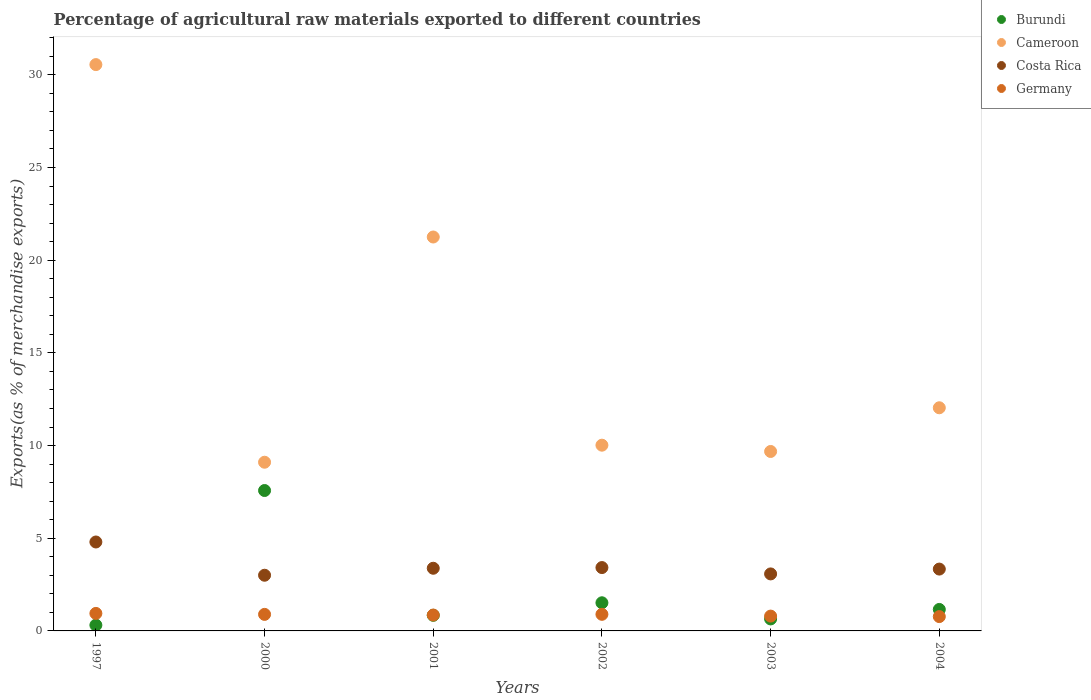Is the number of dotlines equal to the number of legend labels?
Provide a short and direct response. Yes. What is the percentage of exports to different countries in Cameroon in 2003?
Give a very brief answer. 9.68. Across all years, what is the maximum percentage of exports to different countries in Burundi?
Give a very brief answer. 7.57. Across all years, what is the minimum percentage of exports to different countries in Costa Rica?
Keep it short and to the point. 3. In which year was the percentage of exports to different countries in Cameroon maximum?
Your response must be concise. 1997. What is the total percentage of exports to different countries in Cameroon in the graph?
Offer a very short reply. 92.64. What is the difference between the percentage of exports to different countries in Burundi in 2000 and that in 2003?
Offer a very short reply. 6.93. What is the difference between the percentage of exports to different countries in Costa Rica in 2002 and the percentage of exports to different countries in Burundi in 1997?
Provide a short and direct response. 3.1. What is the average percentage of exports to different countries in Burundi per year?
Provide a succinct answer. 2.01. In the year 2001, what is the difference between the percentage of exports to different countries in Cameroon and percentage of exports to different countries in Costa Rica?
Your answer should be very brief. 17.87. What is the ratio of the percentage of exports to different countries in Costa Rica in 2000 to that in 2002?
Give a very brief answer. 0.88. Is the difference between the percentage of exports to different countries in Cameroon in 2000 and 2002 greater than the difference between the percentage of exports to different countries in Costa Rica in 2000 and 2002?
Your answer should be compact. No. What is the difference between the highest and the second highest percentage of exports to different countries in Burundi?
Your response must be concise. 6.06. What is the difference between the highest and the lowest percentage of exports to different countries in Cameroon?
Ensure brevity in your answer.  21.45. In how many years, is the percentage of exports to different countries in Costa Rica greater than the average percentage of exports to different countries in Costa Rica taken over all years?
Offer a very short reply. 1. Is the sum of the percentage of exports to different countries in Costa Rica in 2000 and 2003 greater than the maximum percentage of exports to different countries in Burundi across all years?
Ensure brevity in your answer.  No. Is it the case that in every year, the sum of the percentage of exports to different countries in Costa Rica and percentage of exports to different countries in Cameroon  is greater than the sum of percentage of exports to different countries in Germany and percentage of exports to different countries in Burundi?
Your answer should be very brief. Yes. Is it the case that in every year, the sum of the percentage of exports to different countries in Germany and percentage of exports to different countries in Burundi  is greater than the percentage of exports to different countries in Cameroon?
Offer a very short reply. No. Does the percentage of exports to different countries in Germany monotonically increase over the years?
Offer a terse response. No. Is the percentage of exports to different countries in Cameroon strictly less than the percentage of exports to different countries in Germany over the years?
Your answer should be very brief. No. Are the values on the major ticks of Y-axis written in scientific E-notation?
Offer a very short reply. No. Does the graph contain grids?
Provide a succinct answer. No. How are the legend labels stacked?
Your answer should be very brief. Vertical. What is the title of the graph?
Give a very brief answer. Percentage of agricultural raw materials exported to different countries. What is the label or title of the X-axis?
Your answer should be very brief. Years. What is the label or title of the Y-axis?
Keep it short and to the point. Exports(as % of merchandise exports). What is the Exports(as % of merchandise exports) in Burundi in 1997?
Offer a terse response. 0.31. What is the Exports(as % of merchandise exports) in Cameroon in 1997?
Offer a very short reply. 30.55. What is the Exports(as % of merchandise exports) in Costa Rica in 1997?
Keep it short and to the point. 4.8. What is the Exports(as % of merchandise exports) of Germany in 1997?
Provide a short and direct response. 0.94. What is the Exports(as % of merchandise exports) in Burundi in 2000?
Provide a short and direct response. 7.57. What is the Exports(as % of merchandise exports) in Cameroon in 2000?
Provide a short and direct response. 9.1. What is the Exports(as % of merchandise exports) in Costa Rica in 2000?
Make the answer very short. 3. What is the Exports(as % of merchandise exports) in Germany in 2000?
Offer a very short reply. 0.89. What is the Exports(as % of merchandise exports) in Burundi in 2001?
Provide a short and direct response. 0.84. What is the Exports(as % of merchandise exports) of Cameroon in 2001?
Provide a short and direct response. 21.25. What is the Exports(as % of merchandise exports) in Costa Rica in 2001?
Keep it short and to the point. 3.38. What is the Exports(as % of merchandise exports) of Germany in 2001?
Give a very brief answer. 0.86. What is the Exports(as % of merchandise exports) of Burundi in 2002?
Keep it short and to the point. 1.52. What is the Exports(as % of merchandise exports) in Cameroon in 2002?
Your answer should be very brief. 10.02. What is the Exports(as % of merchandise exports) in Costa Rica in 2002?
Ensure brevity in your answer.  3.42. What is the Exports(as % of merchandise exports) of Germany in 2002?
Offer a very short reply. 0.9. What is the Exports(as % of merchandise exports) of Burundi in 2003?
Ensure brevity in your answer.  0.65. What is the Exports(as % of merchandise exports) of Cameroon in 2003?
Make the answer very short. 9.68. What is the Exports(as % of merchandise exports) of Costa Rica in 2003?
Give a very brief answer. 3.08. What is the Exports(as % of merchandise exports) in Germany in 2003?
Your answer should be very brief. 0.8. What is the Exports(as % of merchandise exports) in Burundi in 2004?
Give a very brief answer. 1.16. What is the Exports(as % of merchandise exports) in Cameroon in 2004?
Offer a terse response. 12.04. What is the Exports(as % of merchandise exports) in Costa Rica in 2004?
Offer a terse response. 3.34. What is the Exports(as % of merchandise exports) of Germany in 2004?
Give a very brief answer. 0.77. Across all years, what is the maximum Exports(as % of merchandise exports) in Burundi?
Your response must be concise. 7.57. Across all years, what is the maximum Exports(as % of merchandise exports) of Cameroon?
Provide a short and direct response. 30.55. Across all years, what is the maximum Exports(as % of merchandise exports) of Costa Rica?
Your answer should be compact. 4.8. Across all years, what is the maximum Exports(as % of merchandise exports) of Germany?
Your response must be concise. 0.94. Across all years, what is the minimum Exports(as % of merchandise exports) of Burundi?
Provide a succinct answer. 0.31. Across all years, what is the minimum Exports(as % of merchandise exports) of Cameroon?
Make the answer very short. 9.1. Across all years, what is the minimum Exports(as % of merchandise exports) of Costa Rica?
Your response must be concise. 3. Across all years, what is the minimum Exports(as % of merchandise exports) in Germany?
Provide a short and direct response. 0.77. What is the total Exports(as % of merchandise exports) of Burundi in the graph?
Offer a very short reply. 12.05. What is the total Exports(as % of merchandise exports) in Cameroon in the graph?
Provide a succinct answer. 92.64. What is the total Exports(as % of merchandise exports) in Costa Rica in the graph?
Offer a very short reply. 21.01. What is the total Exports(as % of merchandise exports) of Germany in the graph?
Your answer should be compact. 5.16. What is the difference between the Exports(as % of merchandise exports) in Burundi in 1997 and that in 2000?
Your answer should be compact. -7.26. What is the difference between the Exports(as % of merchandise exports) in Cameroon in 1997 and that in 2000?
Keep it short and to the point. 21.45. What is the difference between the Exports(as % of merchandise exports) in Costa Rica in 1997 and that in 2000?
Offer a very short reply. 1.79. What is the difference between the Exports(as % of merchandise exports) of Germany in 1997 and that in 2000?
Offer a very short reply. 0.05. What is the difference between the Exports(as % of merchandise exports) in Burundi in 1997 and that in 2001?
Provide a succinct answer. -0.53. What is the difference between the Exports(as % of merchandise exports) in Cameroon in 1997 and that in 2001?
Keep it short and to the point. 9.3. What is the difference between the Exports(as % of merchandise exports) in Costa Rica in 1997 and that in 2001?
Keep it short and to the point. 1.42. What is the difference between the Exports(as % of merchandise exports) of Germany in 1997 and that in 2001?
Ensure brevity in your answer.  0.09. What is the difference between the Exports(as % of merchandise exports) of Burundi in 1997 and that in 2002?
Provide a short and direct response. -1.21. What is the difference between the Exports(as % of merchandise exports) in Cameroon in 1997 and that in 2002?
Your response must be concise. 20.53. What is the difference between the Exports(as % of merchandise exports) in Costa Rica in 1997 and that in 2002?
Offer a terse response. 1.38. What is the difference between the Exports(as % of merchandise exports) in Germany in 1997 and that in 2002?
Your answer should be very brief. 0.05. What is the difference between the Exports(as % of merchandise exports) in Burundi in 1997 and that in 2003?
Your answer should be compact. -0.33. What is the difference between the Exports(as % of merchandise exports) in Cameroon in 1997 and that in 2003?
Keep it short and to the point. 20.87. What is the difference between the Exports(as % of merchandise exports) in Costa Rica in 1997 and that in 2003?
Offer a terse response. 1.72. What is the difference between the Exports(as % of merchandise exports) in Germany in 1997 and that in 2003?
Your answer should be very brief. 0.14. What is the difference between the Exports(as % of merchandise exports) in Burundi in 1997 and that in 2004?
Offer a very short reply. -0.85. What is the difference between the Exports(as % of merchandise exports) of Cameroon in 1997 and that in 2004?
Provide a succinct answer. 18.51. What is the difference between the Exports(as % of merchandise exports) in Costa Rica in 1997 and that in 2004?
Give a very brief answer. 1.46. What is the difference between the Exports(as % of merchandise exports) in Germany in 1997 and that in 2004?
Keep it short and to the point. 0.17. What is the difference between the Exports(as % of merchandise exports) in Burundi in 2000 and that in 2001?
Ensure brevity in your answer.  6.73. What is the difference between the Exports(as % of merchandise exports) of Cameroon in 2000 and that in 2001?
Make the answer very short. -12.15. What is the difference between the Exports(as % of merchandise exports) of Costa Rica in 2000 and that in 2001?
Your answer should be very brief. -0.38. What is the difference between the Exports(as % of merchandise exports) of Germany in 2000 and that in 2001?
Keep it short and to the point. 0.04. What is the difference between the Exports(as % of merchandise exports) of Burundi in 2000 and that in 2002?
Give a very brief answer. 6.06. What is the difference between the Exports(as % of merchandise exports) in Cameroon in 2000 and that in 2002?
Provide a succinct answer. -0.92. What is the difference between the Exports(as % of merchandise exports) of Costa Rica in 2000 and that in 2002?
Your answer should be compact. -0.41. What is the difference between the Exports(as % of merchandise exports) in Germany in 2000 and that in 2002?
Make the answer very short. -0. What is the difference between the Exports(as % of merchandise exports) of Burundi in 2000 and that in 2003?
Your answer should be very brief. 6.93. What is the difference between the Exports(as % of merchandise exports) in Cameroon in 2000 and that in 2003?
Ensure brevity in your answer.  -0.58. What is the difference between the Exports(as % of merchandise exports) in Costa Rica in 2000 and that in 2003?
Give a very brief answer. -0.07. What is the difference between the Exports(as % of merchandise exports) in Germany in 2000 and that in 2003?
Offer a very short reply. 0.09. What is the difference between the Exports(as % of merchandise exports) in Burundi in 2000 and that in 2004?
Provide a succinct answer. 6.42. What is the difference between the Exports(as % of merchandise exports) in Cameroon in 2000 and that in 2004?
Your answer should be very brief. -2.94. What is the difference between the Exports(as % of merchandise exports) of Costa Rica in 2000 and that in 2004?
Offer a terse response. -0.33. What is the difference between the Exports(as % of merchandise exports) of Germany in 2000 and that in 2004?
Your answer should be very brief. 0.12. What is the difference between the Exports(as % of merchandise exports) in Burundi in 2001 and that in 2002?
Make the answer very short. -0.68. What is the difference between the Exports(as % of merchandise exports) in Cameroon in 2001 and that in 2002?
Offer a very short reply. 11.23. What is the difference between the Exports(as % of merchandise exports) of Costa Rica in 2001 and that in 2002?
Make the answer very short. -0.04. What is the difference between the Exports(as % of merchandise exports) in Germany in 2001 and that in 2002?
Your answer should be very brief. -0.04. What is the difference between the Exports(as % of merchandise exports) of Burundi in 2001 and that in 2003?
Keep it short and to the point. 0.19. What is the difference between the Exports(as % of merchandise exports) of Cameroon in 2001 and that in 2003?
Provide a succinct answer. 11.57. What is the difference between the Exports(as % of merchandise exports) of Costa Rica in 2001 and that in 2003?
Ensure brevity in your answer.  0.31. What is the difference between the Exports(as % of merchandise exports) of Germany in 2001 and that in 2003?
Ensure brevity in your answer.  0.06. What is the difference between the Exports(as % of merchandise exports) in Burundi in 2001 and that in 2004?
Offer a terse response. -0.32. What is the difference between the Exports(as % of merchandise exports) of Cameroon in 2001 and that in 2004?
Provide a succinct answer. 9.21. What is the difference between the Exports(as % of merchandise exports) in Costa Rica in 2001 and that in 2004?
Provide a succinct answer. 0.04. What is the difference between the Exports(as % of merchandise exports) in Germany in 2001 and that in 2004?
Your answer should be compact. 0.08. What is the difference between the Exports(as % of merchandise exports) in Burundi in 2002 and that in 2003?
Your answer should be very brief. 0.87. What is the difference between the Exports(as % of merchandise exports) in Cameroon in 2002 and that in 2003?
Give a very brief answer. 0.34. What is the difference between the Exports(as % of merchandise exports) in Costa Rica in 2002 and that in 2003?
Give a very brief answer. 0.34. What is the difference between the Exports(as % of merchandise exports) of Germany in 2002 and that in 2003?
Offer a very short reply. 0.1. What is the difference between the Exports(as % of merchandise exports) of Burundi in 2002 and that in 2004?
Make the answer very short. 0.36. What is the difference between the Exports(as % of merchandise exports) of Cameroon in 2002 and that in 2004?
Your response must be concise. -2.02. What is the difference between the Exports(as % of merchandise exports) in Costa Rica in 2002 and that in 2004?
Make the answer very short. 0.08. What is the difference between the Exports(as % of merchandise exports) of Germany in 2002 and that in 2004?
Give a very brief answer. 0.12. What is the difference between the Exports(as % of merchandise exports) of Burundi in 2003 and that in 2004?
Provide a short and direct response. -0.51. What is the difference between the Exports(as % of merchandise exports) of Cameroon in 2003 and that in 2004?
Your answer should be very brief. -2.36. What is the difference between the Exports(as % of merchandise exports) in Costa Rica in 2003 and that in 2004?
Your answer should be compact. -0.26. What is the difference between the Exports(as % of merchandise exports) of Germany in 2003 and that in 2004?
Ensure brevity in your answer.  0.03. What is the difference between the Exports(as % of merchandise exports) in Burundi in 1997 and the Exports(as % of merchandise exports) in Cameroon in 2000?
Offer a terse response. -8.79. What is the difference between the Exports(as % of merchandise exports) in Burundi in 1997 and the Exports(as % of merchandise exports) in Costa Rica in 2000?
Give a very brief answer. -2.69. What is the difference between the Exports(as % of merchandise exports) in Burundi in 1997 and the Exports(as % of merchandise exports) in Germany in 2000?
Offer a terse response. -0.58. What is the difference between the Exports(as % of merchandise exports) of Cameroon in 1997 and the Exports(as % of merchandise exports) of Costa Rica in 2000?
Ensure brevity in your answer.  27.55. What is the difference between the Exports(as % of merchandise exports) of Cameroon in 1997 and the Exports(as % of merchandise exports) of Germany in 2000?
Provide a succinct answer. 29.66. What is the difference between the Exports(as % of merchandise exports) in Costa Rica in 1997 and the Exports(as % of merchandise exports) in Germany in 2000?
Your answer should be very brief. 3.91. What is the difference between the Exports(as % of merchandise exports) in Burundi in 1997 and the Exports(as % of merchandise exports) in Cameroon in 2001?
Your answer should be very brief. -20.94. What is the difference between the Exports(as % of merchandise exports) in Burundi in 1997 and the Exports(as % of merchandise exports) in Costa Rica in 2001?
Make the answer very short. -3.07. What is the difference between the Exports(as % of merchandise exports) in Burundi in 1997 and the Exports(as % of merchandise exports) in Germany in 2001?
Your answer should be compact. -0.54. What is the difference between the Exports(as % of merchandise exports) of Cameroon in 1997 and the Exports(as % of merchandise exports) of Costa Rica in 2001?
Keep it short and to the point. 27.17. What is the difference between the Exports(as % of merchandise exports) in Cameroon in 1997 and the Exports(as % of merchandise exports) in Germany in 2001?
Ensure brevity in your answer.  29.69. What is the difference between the Exports(as % of merchandise exports) of Costa Rica in 1997 and the Exports(as % of merchandise exports) of Germany in 2001?
Ensure brevity in your answer.  3.94. What is the difference between the Exports(as % of merchandise exports) of Burundi in 1997 and the Exports(as % of merchandise exports) of Cameroon in 2002?
Offer a very short reply. -9.71. What is the difference between the Exports(as % of merchandise exports) of Burundi in 1997 and the Exports(as % of merchandise exports) of Costa Rica in 2002?
Give a very brief answer. -3.1. What is the difference between the Exports(as % of merchandise exports) in Burundi in 1997 and the Exports(as % of merchandise exports) in Germany in 2002?
Offer a terse response. -0.58. What is the difference between the Exports(as % of merchandise exports) of Cameroon in 1997 and the Exports(as % of merchandise exports) of Costa Rica in 2002?
Provide a short and direct response. 27.13. What is the difference between the Exports(as % of merchandise exports) of Cameroon in 1997 and the Exports(as % of merchandise exports) of Germany in 2002?
Ensure brevity in your answer.  29.66. What is the difference between the Exports(as % of merchandise exports) of Costa Rica in 1997 and the Exports(as % of merchandise exports) of Germany in 2002?
Your answer should be compact. 3.9. What is the difference between the Exports(as % of merchandise exports) in Burundi in 1997 and the Exports(as % of merchandise exports) in Cameroon in 2003?
Make the answer very short. -9.37. What is the difference between the Exports(as % of merchandise exports) of Burundi in 1997 and the Exports(as % of merchandise exports) of Costa Rica in 2003?
Provide a short and direct response. -2.76. What is the difference between the Exports(as % of merchandise exports) in Burundi in 1997 and the Exports(as % of merchandise exports) in Germany in 2003?
Provide a succinct answer. -0.49. What is the difference between the Exports(as % of merchandise exports) of Cameroon in 1997 and the Exports(as % of merchandise exports) of Costa Rica in 2003?
Provide a succinct answer. 27.48. What is the difference between the Exports(as % of merchandise exports) in Cameroon in 1997 and the Exports(as % of merchandise exports) in Germany in 2003?
Your response must be concise. 29.75. What is the difference between the Exports(as % of merchandise exports) of Costa Rica in 1997 and the Exports(as % of merchandise exports) of Germany in 2003?
Provide a succinct answer. 4. What is the difference between the Exports(as % of merchandise exports) of Burundi in 1997 and the Exports(as % of merchandise exports) of Cameroon in 2004?
Offer a very short reply. -11.73. What is the difference between the Exports(as % of merchandise exports) of Burundi in 1997 and the Exports(as % of merchandise exports) of Costa Rica in 2004?
Offer a very short reply. -3.02. What is the difference between the Exports(as % of merchandise exports) in Burundi in 1997 and the Exports(as % of merchandise exports) in Germany in 2004?
Provide a short and direct response. -0.46. What is the difference between the Exports(as % of merchandise exports) of Cameroon in 1997 and the Exports(as % of merchandise exports) of Costa Rica in 2004?
Offer a very short reply. 27.21. What is the difference between the Exports(as % of merchandise exports) in Cameroon in 1997 and the Exports(as % of merchandise exports) in Germany in 2004?
Offer a terse response. 29.78. What is the difference between the Exports(as % of merchandise exports) of Costa Rica in 1997 and the Exports(as % of merchandise exports) of Germany in 2004?
Make the answer very short. 4.02. What is the difference between the Exports(as % of merchandise exports) in Burundi in 2000 and the Exports(as % of merchandise exports) in Cameroon in 2001?
Give a very brief answer. -13.68. What is the difference between the Exports(as % of merchandise exports) in Burundi in 2000 and the Exports(as % of merchandise exports) in Costa Rica in 2001?
Offer a terse response. 4.19. What is the difference between the Exports(as % of merchandise exports) in Burundi in 2000 and the Exports(as % of merchandise exports) in Germany in 2001?
Provide a succinct answer. 6.72. What is the difference between the Exports(as % of merchandise exports) in Cameroon in 2000 and the Exports(as % of merchandise exports) in Costa Rica in 2001?
Provide a short and direct response. 5.72. What is the difference between the Exports(as % of merchandise exports) of Cameroon in 2000 and the Exports(as % of merchandise exports) of Germany in 2001?
Offer a very short reply. 8.24. What is the difference between the Exports(as % of merchandise exports) in Costa Rica in 2000 and the Exports(as % of merchandise exports) in Germany in 2001?
Provide a succinct answer. 2.15. What is the difference between the Exports(as % of merchandise exports) in Burundi in 2000 and the Exports(as % of merchandise exports) in Cameroon in 2002?
Make the answer very short. -2.45. What is the difference between the Exports(as % of merchandise exports) in Burundi in 2000 and the Exports(as % of merchandise exports) in Costa Rica in 2002?
Your answer should be very brief. 4.16. What is the difference between the Exports(as % of merchandise exports) of Burundi in 2000 and the Exports(as % of merchandise exports) of Germany in 2002?
Offer a very short reply. 6.68. What is the difference between the Exports(as % of merchandise exports) in Cameroon in 2000 and the Exports(as % of merchandise exports) in Costa Rica in 2002?
Ensure brevity in your answer.  5.68. What is the difference between the Exports(as % of merchandise exports) in Cameroon in 2000 and the Exports(as % of merchandise exports) in Germany in 2002?
Ensure brevity in your answer.  8.2. What is the difference between the Exports(as % of merchandise exports) of Costa Rica in 2000 and the Exports(as % of merchandise exports) of Germany in 2002?
Provide a short and direct response. 2.11. What is the difference between the Exports(as % of merchandise exports) of Burundi in 2000 and the Exports(as % of merchandise exports) of Cameroon in 2003?
Your answer should be compact. -2.11. What is the difference between the Exports(as % of merchandise exports) in Burundi in 2000 and the Exports(as % of merchandise exports) in Costa Rica in 2003?
Give a very brief answer. 4.5. What is the difference between the Exports(as % of merchandise exports) of Burundi in 2000 and the Exports(as % of merchandise exports) of Germany in 2003?
Your answer should be compact. 6.77. What is the difference between the Exports(as % of merchandise exports) of Cameroon in 2000 and the Exports(as % of merchandise exports) of Costa Rica in 2003?
Your response must be concise. 6.02. What is the difference between the Exports(as % of merchandise exports) in Cameroon in 2000 and the Exports(as % of merchandise exports) in Germany in 2003?
Give a very brief answer. 8.3. What is the difference between the Exports(as % of merchandise exports) of Costa Rica in 2000 and the Exports(as % of merchandise exports) of Germany in 2003?
Make the answer very short. 2.2. What is the difference between the Exports(as % of merchandise exports) of Burundi in 2000 and the Exports(as % of merchandise exports) of Cameroon in 2004?
Ensure brevity in your answer.  -4.46. What is the difference between the Exports(as % of merchandise exports) in Burundi in 2000 and the Exports(as % of merchandise exports) in Costa Rica in 2004?
Ensure brevity in your answer.  4.24. What is the difference between the Exports(as % of merchandise exports) of Burundi in 2000 and the Exports(as % of merchandise exports) of Germany in 2004?
Your answer should be compact. 6.8. What is the difference between the Exports(as % of merchandise exports) of Cameroon in 2000 and the Exports(as % of merchandise exports) of Costa Rica in 2004?
Provide a short and direct response. 5.76. What is the difference between the Exports(as % of merchandise exports) in Cameroon in 2000 and the Exports(as % of merchandise exports) in Germany in 2004?
Provide a short and direct response. 8.33. What is the difference between the Exports(as % of merchandise exports) in Costa Rica in 2000 and the Exports(as % of merchandise exports) in Germany in 2004?
Keep it short and to the point. 2.23. What is the difference between the Exports(as % of merchandise exports) of Burundi in 2001 and the Exports(as % of merchandise exports) of Cameroon in 2002?
Your answer should be compact. -9.18. What is the difference between the Exports(as % of merchandise exports) of Burundi in 2001 and the Exports(as % of merchandise exports) of Costa Rica in 2002?
Ensure brevity in your answer.  -2.58. What is the difference between the Exports(as % of merchandise exports) of Burundi in 2001 and the Exports(as % of merchandise exports) of Germany in 2002?
Make the answer very short. -0.05. What is the difference between the Exports(as % of merchandise exports) of Cameroon in 2001 and the Exports(as % of merchandise exports) of Costa Rica in 2002?
Provide a short and direct response. 17.83. What is the difference between the Exports(as % of merchandise exports) in Cameroon in 2001 and the Exports(as % of merchandise exports) in Germany in 2002?
Your response must be concise. 20.35. What is the difference between the Exports(as % of merchandise exports) of Costa Rica in 2001 and the Exports(as % of merchandise exports) of Germany in 2002?
Your answer should be compact. 2.49. What is the difference between the Exports(as % of merchandise exports) in Burundi in 2001 and the Exports(as % of merchandise exports) in Cameroon in 2003?
Make the answer very short. -8.84. What is the difference between the Exports(as % of merchandise exports) of Burundi in 2001 and the Exports(as % of merchandise exports) of Costa Rica in 2003?
Keep it short and to the point. -2.23. What is the difference between the Exports(as % of merchandise exports) in Burundi in 2001 and the Exports(as % of merchandise exports) in Germany in 2003?
Provide a short and direct response. 0.04. What is the difference between the Exports(as % of merchandise exports) of Cameroon in 2001 and the Exports(as % of merchandise exports) of Costa Rica in 2003?
Give a very brief answer. 18.17. What is the difference between the Exports(as % of merchandise exports) of Cameroon in 2001 and the Exports(as % of merchandise exports) of Germany in 2003?
Keep it short and to the point. 20.45. What is the difference between the Exports(as % of merchandise exports) of Costa Rica in 2001 and the Exports(as % of merchandise exports) of Germany in 2003?
Your answer should be very brief. 2.58. What is the difference between the Exports(as % of merchandise exports) in Burundi in 2001 and the Exports(as % of merchandise exports) in Cameroon in 2004?
Keep it short and to the point. -11.2. What is the difference between the Exports(as % of merchandise exports) of Burundi in 2001 and the Exports(as % of merchandise exports) of Costa Rica in 2004?
Offer a terse response. -2.49. What is the difference between the Exports(as % of merchandise exports) of Burundi in 2001 and the Exports(as % of merchandise exports) of Germany in 2004?
Ensure brevity in your answer.  0.07. What is the difference between the Exports(as % of merchandise exports) of Cameroon in 2001 and the Exports(as % of merchandise exports) of Costa Rica in 2004?
Your answer should be compact. 17.91. What is the difference between the Exports(as % of merchandise exports) in Cameroon in 2001 and the Exports(as % of merchandise exports) in Germany in 2004?
Your answer should be very brief. 20.48. What is the difference between the Exports(as % of merchandise exports) in Costa Rica in 2001 and the Exports(as % of merchandise exports) in Germany in 2004?
Provide a succinct answer. 2.61. What is the difference between the Exports(as % of merchandise exports) in Burundi in 2002 and the Exports(as % of merchandise exports) in Cameroon in 2003?
Offer a very short reply. -8.16. What is the difference between the Exports(as % of merchandise exports) of Burundi in 2002 and the Exports(as % of merchandise exports) of Costa Rica in 2003?
Provide a succinct answer. -1.56. What is the difference between the Exports(as % of merchandise exports) in Burundi in 2002 and the Exports(as % of merchandise exports) in Germany in 2003?
Offer a very short reply. 0.72. What is the difference between the Exports(as % of merchandise exports) of Cameroon in 2002 and the Exports(as % of merchandise exports) of Costa Rica in 2003?
Your answer should be very brief. 6.94. What is the difference between the Exports(as % of merchandise exports) in Cameroon in 2002 and the Exports(as % of merchandise exports) in Germany in 2003?
Offer a very short reply. 9.22. What is the difference between the Exports(as % of merchandise exports) of Costa Rica in 2002 and the Exports(as % of merchandise exports) of Germany in 2003?
Keep it short and to the point. 2.62. What is the difference between the Exports(as % of merchandise exports) of Burundi in 2002 and the Exports(as % of merchandise exports) of Cameroon in 2004?
Your answer should be very brief. -10.52. What is the difference between the Exports(as % of merchandise exports) in Burundi in 2002 and the Exports(as % of merchandise exports) in Costa Rica in 2004?
Ensure brevity in your answer.  -1.82. What is the difference between the Exports(as % of merchandise exports) of Burundi in 2002 and the Exports(as % of merchandise exports) of Germany in 2004?
Make the answer very short. 0.74. What is the difference between the Exports(as % of merchandise exports) in Cameroon in 2002 and the Exports(as % of merchandise exports) in Costa Rica in 2004?
Provide a succinct answer. 6.68. What is the difference between the Exports(as % of merchandise exports) in Cameroon in 2002 and the Exports(as % of merchandise exports) in Germany in 2004?
Keep it short and to the point. 9.25. What is the difference between the Exports(as % of merchandise exports) of Costa Rica in 2002 and the Exports(as % of merchandise exports) of Germany in 2004?
Offer a terse response. 2.64. What is the difference between the Exports(as % of merchandise exports) in Burundi in 2003 and the Exports(as % of merchandise exports) in Cameroon in 2004?
Your answer should be compact. -11.39. What is the difference between the Exports(as % of merchandise exports) in Burundi in 2003 and the Exports(as % of merchandise exports) in Costa Rica in 2004?
Provide a short and direct response. -2.69. What is the difference between the Exports(as % of merchandise exports) in Burundi in 2003 and the Exports(as % of merchandise exports) in Germany in 2004?
Your answer should be compact. -0.13. What is the difference between the Exports(as % of merchandise exports) in Cameroon in 2003 and the Exports(as % of merchandise exports) in Costa Rica in 2004?
Provide a succinct answer. 6.34. What is the difference between the Exports(as % of merchandise exports) of Cameroon in 2003 and the Exports(as % of merchandise exports) of Germany in 2004?
Keep it short and to the point. 8.91. What is the difference between the Exports(as % of merchandise exports) of Costa Rica in 2003 and the Exports(as % of merchandise exports) of Germany in 2004?
Keep it short and to the point. 2.3. What is the average Exports(as % of merchandise exports) in Burundi per year?
Give a very brief answer. 2.01. What is the average Exports(as % of merchandise exports) of Cameroon per year?
Give a very brief answer. 15.44. What is the average Exports(as % of merchandise exports) of Costa Rica per year?
Offer a very short reply. 3.5. What is the average Exports(as % of merchandise exports) in Germany per year?
Provide a succinct answer. 0.86. In the year 1997, what is the difference between the Exports(as % of merchandise exports) in Burundi and Exports(as % of merchandise exports) in Cameroon?
Offer a very short reply. -30.24. In the year 1997, what is the difference between the Exports(as % of merchandise exports) in Burundi and Exports(as % of merchandise exports) in Costa Rica?
Make the answer very short. -4.48. In the year 1997, what is the difference between the Exports(as % of merchandise exports) of Burundi and Exports(as % of merchandise exports) of Germany?
Make the answer very short. -0.63. In the year 1997, what is the difference between the Exports(as % of merchandise exports) of Cameroon and Exports(as % of merchandise exports) of Costa Rica?
Make the answer very short. 25.75. In the year 1997, what is the difference between the Exports(as % of merchandise exports) of Cameroon and Exports(as % of merchandise exports) of Germany?
Ensure brevity in your answer.  29.61. In the year 1997, what is the difference between the Exports(as % of merchandise exports) in Costa Rica and Exports(as % of merchandise exports) in Germany?
Provide a succinct answer. 3.85. In the year 2000, what is the difference between the Exports(as % of merchandise exports) in Burundi and Exports(as % of merchandise exports) in Cameroon?
Make the answer very short. -1.53. In the year 2000, what is the difference between the Exports(as % of merchandise exports) in Burundi and Exports(as % of merchandise exports) in Costa Rica?
Give a very brief answer. 4.57. In the year 2000, what is the difference between the Exports(as % of merchandise exports) of Burundi and Exports(as % of merchandise exports) of Germany?
Offer a very short reply. 6.68. In the year 2000, what is the difference between the Exports(as % of merchandise exports) in Cameroon and Exports(as % of merchandise exports) in Costa Rica?
Ensure brevity in your answer.  6.1. In the year 2000, what is the difference between the Exports(as % of merchandise exports) in Cameroon and Exports(as % of merchandise exports) in Germany?
Ensure brevity in your answer.  8.21. In the year 2000, what is the difference between the Exports(as % of merchandise exports) in Costa Rica and Exports(as % of merchandise exports) in Germany?
Your answer should be very brief. 2.11. In the year 2001, what is the difference between the Exports(as % of merchandise exports) of Burundi and Exports(as % of merchandise exports) of Cameroon?
Your answer should be compact. -20.41. In the year 2001, what is the difference between the Exports(as % of merchandise exports) in Burundi and Exports(as % of merchandise exports) in Costa Rica?
Give a very brief answer. -2.54. In the year 2001, what is the difference between the Exports(as % of merchandise exports) in Burundi and Exports(as % of merchandise exports) in Germany?
Keep it short and to the point. -0.02. In the year 2001, what is the difference between the Exports(as % of merchandise exports) of Cameroon and Exports(as % of merchandise exports) of Costa Rica?
Make the answer very short. 17.87. In the year 2001, what is the difference between the Exports(as % of merchandise exports) in Cameroon and Exports(as % of merchandise exports) in Germany?
Offer a terse response. 20.39. In the year 2001, what is the difference between the Exports(as % of merchandise exports) in Costa Rica and Exports(as % of merchandise exports) in Germany?
Ensure brevity in your answer.  2.52. In the year 2002, what is the difference between the Exports(as % of merchandise exports) of Burundi and Exports(as % of merchandise exports) of Cameroon?
Offer a very short reply. -8.5. In the year 2002, what is the difference between the Exports(as % of merchandise exports) in Burundi and Exports(as % of merchandise exports) in Costa Rica?
Your answer should be very brief. -1.9. In the year 2002, what is the difference between the Exports(as % of merchandise exports) of Burundi and Exports(as % of merchandise exports) of Germany?
Offer a terse response. 0.62. In the year 2002, what is the difference between the Exports(as % of merchandise exports) of Cameroon and Exports(as % of merchandise exports) of Costa Rica?
Provide a succinct answer. 6.6. In the year 2002, what is the difference between the Exports(as % of merchandise exports) of Cameroon and Exports(as % of merchandise exports) of Germany?
Ensure brevity in your answer.  9.12. In the year 2002, what is the difference between the Exports(as % of merchandise exports) of Costa Rica and Exports(as % of merchandise exports) of Germany?
Your response must be concise. 2.52. In the year 2003, what is the difference between the Exports(as % of merchandise exports) in Burundi and Exports(as % of merchandise exports) in Cameroon?
Your answer should be compact. -9.03. In the year 2003, what is the difference between the Exports(as % of merchandise exports) of Burundi and Exports(as % of merchandise exports) of Costa Rica?
Your response must be concise. -2.43. In the year 2003, what is the difference between the Exports(as % of merchandise exports) of Burundi and Exports(as % of merchandise exports) of Germany?
Your answer should be very brief. -0.15. In the year 2003, what is the difference between the Exports(as % of merchandise exports) in Cameroon and Exports(as % of merchandise exports) in Costa Rica?
Your response must be concise. 6.61. In the year 2003, what is the difference between the Exports(as % of merchandise exports) of Cameroon and Exports(as % of merchandise exports) of Germany?
Ensure brevity in your answer.  8.88. In the year 2003, what is the difference between the Exports(as % of merchandise exports) in Costa Rica and Exports(as % of merchandise exports) in Germany?
Your answer should be very brief. 2.28. In the year 2004, what is the difference between the Exports(as % of merchandise exports) in Burundi and Exports(as % of merchandise exports) in Cameroon?
Your answer should be very brief. -10.88. In the year 2004, what is the difference between the Exports(as % of merchandise exports) of Burundi and Exports(as % of merchandise exports) of Costa Rica?
Keep it short and to the point. -2.18. In the year 2004, what is the difference between the Exports(as % of merchandise exports) of Burundi and Exports(as % of merchandise exports) of Germany?
Offer a very short reply. 0.39. In the year 2004, what is the difference between the Exports(as % of merchandise exports) of Cameroon and Exports(as % of merchandise exports) of Costa Rica?
Ensure brevity in your answer.  8.7. In the year 2004, what is the difference between the Exports(as % of merchandise exports) of Cameroon and Exports(as % of merchandise exports) of Germany?
Ensure brevity in your answer.  11.26. In the year 2004, what is the difference between the Exports(as % of merchandise exports) in Costa Rica and Exports(as % of merchandise exports) in Germany?
Keep it short and to the point. 2.56. What is the ratio of the Exports(as % of merchandise exports) in Burundi in 1997 to that in 2000?
Your response must be concise. 0.04. What is the ratio of the Exports(as % of merchandise exports) of Cameroon in 1997 to that in 2000?
Your response must be concise. 3.36. What is the ratio of the Exports(as % of merchandise exports) of Costa Rica in 1997 to that in 2000?
Provide a succinct answer. 1.6. What is the ratio of the Exports(as % of merchandise exports) of Germany in 1997 to that in 2000?
Offer a very short reply. 1.06. What is the ratio of the Exports(as % of merchandise exports) in Burundi in 1997 to that in 2001?
Give a very brief answer. 0.37. What is the ratio of the Exports(as % of merchandise exports) in Cameroon in 1997 to that in 2001?
Your response must be concise. 1.44. What is the ratio of the Exports(as % of merchandise exports) in Costa Rica in 1997 to that in 2001?
Your answer should be compact. 1.42. What is the ratio of the Exports(as % of merchandise exports) of Germany in 1997 to that in 2001?
Make the answer very short. 1.1. What is the ratio of the Exports(as % of merchandise exports) of Burundi in 1997 to that in 2002?
Offer a very short reply. 0.21. What is the ratio of the Exports(as % of merchandise exports) of Cameroon in 1997 to that in 2002?
Your answer should be compact. 3.05. What is the ratio of the Exports(as % of merchandise exports) in Costa Rica in 1997 to that in 2002?
Keep it short and to the point. 1.4. What is the ratio of the Exports(as % of merchandise exports) of Germany in 1997 to that in 2002?
Keep it short and to the point. 1.05. What is the ratio of the Exports(as % of merchandise exports) of Burundi in 1997 to that in 2003?
Provide a succinct answer. 0.48. What is the ratio of the Exports(as % of merchandise exports) of Cameroon in 1997 to that in 2003?
Offer a very short reply. 3.16. What is the ratio of the Exports(as % of merchandise exports) in Costa Rica in 1997 to that in 2003?
Offer a terse response. 1.56. What is the ratio of the Exports(as % of merchandise exports) of Germany in 1997 to that in 2003?
Provide a short and direct response. 1.18. What is the ratio of the Exports(as % of merchandise exports) in Burundi in 1997 to that in 2004?
Provide a succinct answer. 0.27. What is the ratio of the Exports(as % of merchandise exports) in Cameroon in 1997 to that in 2004?
Your answer should be very brief. 2.54. What is the ratio of the Exports(as % of merchandise exports) in Costa Rica in 1997 to that in 2004?
Make the answer very short. 1.44. What is the ratio of the Exports(as % of merchandise exports) of Germany in 1997 to that in 2004?
Offer a very short reply. 1.22. What is the ratio of the Exports(as % of merchandise exports) in Burundi in 2000 to that in 2001?
Provide a short and direct response. 9. What is the ratio of the Exports(as % of merchandise exports) in Cameroon in 2000 to that in 2001?
Make the answer very short. 0.43. What is the ratio of the Exports(as % of merchandise exports) of Costa Rica in 2000 to that in 2001?
Offer a very short reply. 0.89. What is the ratio of the Exports(as % of merchandise exports) of Germany in 2000 to that in 2001?
Keep it short and to the point. 1.04. What is the ratio of the Exports(as % of merchandise exports) of Burundi in 2000 to that in 2002?
Provide a short and direct response. 4.99. What is the ratio of the Exports(as % of merchandise exports) of Cameroon in 2000 to that in 2002?
Provide a short and direct response. 0.91. What is the ratio of the Exports(as % of merchandise exports) of Costa Rica in 2000 to that in 2002?
Offer a very short reply. 0.88. What is the ratio of the Exports(as % of merchandise exports) in Germany in 2000 to that in 2002?
Provide a short and direct response. 1. What is the ratio of the Exports(as % of merchandise exports) in Burundi in 2000 to that in 2003?
Give a very brief answer. 11.71. What is the ratio of the Exports(as % of merchandise exports) of Costa Rica in 2000 to that in 2003?
Keep it short and to the point. 0.98. What is the ratio of the Exports(as % of merchandise exports) of Germany in 2000 to that in 2003?
Make the answer very short. 1.12. What is the ratio of the Exports(as % of merchandise exports) of Burundi in 2000 to that in 2004?
Provide a short and direct response. 6.53. What is the ratio of the Exports(as % of merchandise exports) of Cameroon in 2000 to that in 2004?
Make the answer very short. 0.76. What is the ratio of the Exports(as % of merchandise exports) of Costa Rica in 2000 to that in 2004?
Your answer should be very brief. 0.9. What is the ratio of the Exports(as % of merchandise exports) in Germany in 2000 to that in 2004?
Your answer should be very brief. 1.15. What is the ratio of the Exports(as % of merchandise exports) of Burundi in 2001 to that in 2002?
Give a very brief answer. 0.55. What is the ratio of the Exports(as % of merchandise exports) of Cameroon in 2001 to that in 2002?
Give a very brief answer. 2.12. What is the ratio of the Exports(as % of merchandise exports) in Germany in 2001 to that in 2002?
Your response must be concise. 0.96. What is the ratio of the Exports(as % of merchandise exports) of Burundi in 2001 to that in 2003?
Give a very brief answer. 1.3. What is the ratio of the Exports(as % of merchandise exports) in Cameroon in 2001 to that in 2003?
Your response must be concise. 2.2. What is the ratio of the Exports(as % of merchandise exports) of Costa Rica in 2001 to that in 2003?
Your answer should be compact. 1.1. What is the ratio of the Exports(as % of merchandise exports) of Germany in 2001 to that in 2003?
Provide a succinct answer. 1.07. What is the ratio of the Exports(as % of merchandise exports) of Burundi in 2001 to that in 2004?
Provide a short and direct response. 0.73. What is the ratio of the Exports(as % of merchandise exports) of Cameroon in 2001 to that in 2004?
Your answer should be compact. 1.77. What is the ratio of the Exports(as % of merchandise exports) in Costa Rica in 2001 to that in 2004?
Your response must be concise. 1.01. What is the ratio of the Exports(as % of merchandise exports) in Germany in 2001 to that in 2004?
Keep it short and to the point. 1.11. What is the ratio of the Exports(as % of merchandise exports) in Burundi in 2002 to that in 2003?
Offer a very short reply. 2.35. What is the ratio of the Exports(as % of merchandise exports) in Cameroon in 2002 to that in 2003?
Your answer should be very brief. 1.03. What is the ratio of the Exports(as % of merchandise exports) in Costa Rica in 2002 to that in 2003?
Make the answer very short. 1.11. What is the ratio of the Exports(as % of merchandise exports) of Germany in 2002 to that in 2003?
Give a very brief answer. 1.12. What is the ratio of the Exports(as % of merchandise exports) of Burundi in 2002 to that in 2004?
Your answer should be very brief. 1.31. What is the ratio of the Exports(as % of merchandise exports) in Cameroon in 2002 to that in 2004?
Make the answer very short. 0.83. What is the ratio of the Exports(as % of merchandise exports) of Costa Rica in 2002 to that in 2004?
Provide a succinct answer. 1.02. What is the ratio of the Exports(as % of merchandise exports) of Germany in 2002 to that in 2004?
Ensure brevity in your answer.  1.16. What is the ratio of the Exports(as % of merchandise exports) of Burundi in 2003 to that in 2004?
Ensure brevity in your answer.  0.56. What is the ratio of the Exports(as % of merchandise exports) of Cameroon in 2003 to that in 2004?
Make the answer very short. 0.8. What is the ratio of the Exports(as % of merchandise exports) in Costa Rica in 2003 to that in 2004?
Make the answer very short. 0.92. What is the ratio of the Exports(as % of merchandise exports) in Germany in 2003 to that in 2004?
Your answer should be compact. 1.03. What is the difference between the highest and the second highest Exports(as % of merchandise exports) in Burundi?
Ensure brevity in your answer.  6.06. What is the difference between the highest and the second highest Exports(as % of merchandise exports) of Cameroon?
Offer a terse response. 9.3. What is the difference between the highest and the second highest Exports(as % of merchandise exports) in Costa Rica?
Provide a short and direct response. 1.38. What is the difference between the highest and the second highest Exports(as % of merchandise exports) of Germany?
Keep it short and to the point. 0.05. What is the difference between the highest and the lowest Exports(as % of merchandise exports) of Burundi?
Provide a succinct answer. 7.26. What is the difference between the highest and the lowest Exports(as % of merchandise exports) in Cameroon?
Ensure brevity in your answer.  21.45. What is the difference between the highest and the lowest Exports(as % of merchandise exports) in Costa Rica?
Provide a succinct answer. 1.79. What is the difference between the highest and the lowest Exports(as % of merchandise exports) in Germany?
Offer a very short reply. 0.17. 